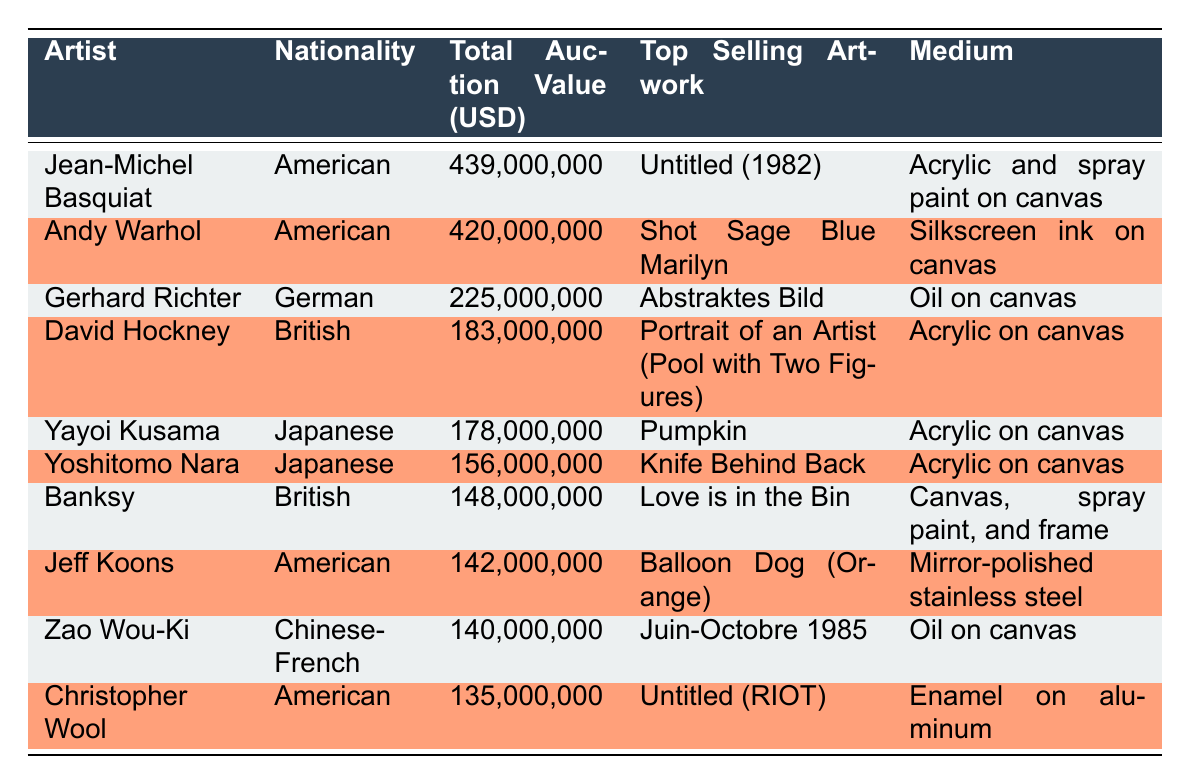What is the total auction value of Jean-Michel Basquiat? The table lists Jean-Michel Basquiat with a total auction value of 439,000,000 USD in the corresponding row.
Answer: 439,000,000 Which artist is the second highest in total auction value? By examining the total auction values from the table, Andy Warhol follows Jean-Michel Basquiat, with 420,000,000 USD.
Answer: Andy Warhol How many artists are from Japan in the table? The table lists two artists from Japan: Yayoi Kusama and Yoshitomo Nara, identified by their nationality in the second column.
Answer: 2 What is the median total auction value of the artists listed? To find the median, we list the total auction values in ascending order: 135,000,000, 140,000,000, 142,000,000, 148,000,000, 156,000,000, 178,000,000, 183,000,000, 225,000,000, 420,000,000, 439,000,000. The middle values (5th and 6th from 10 values total) are 178,000,000 and 183,000,000. The median is (178,000,000 + 183,000,000) / 2 = 180,500,000.
Answer: 180,500,000 Does any artist from Germany appear in the list? Looking at the nationalities in the table, Gerhard Richter is the only artist from Germany included.
Answer: Yes Which medium is used for the top-selling artwork by Yoko Kusama? The top-selling artwork by Yayoi Kusama is "Pumpkin," and it is identified as Acrylic on canvas in the corresponding row of the table.
Answer: Acrylic on canvas 